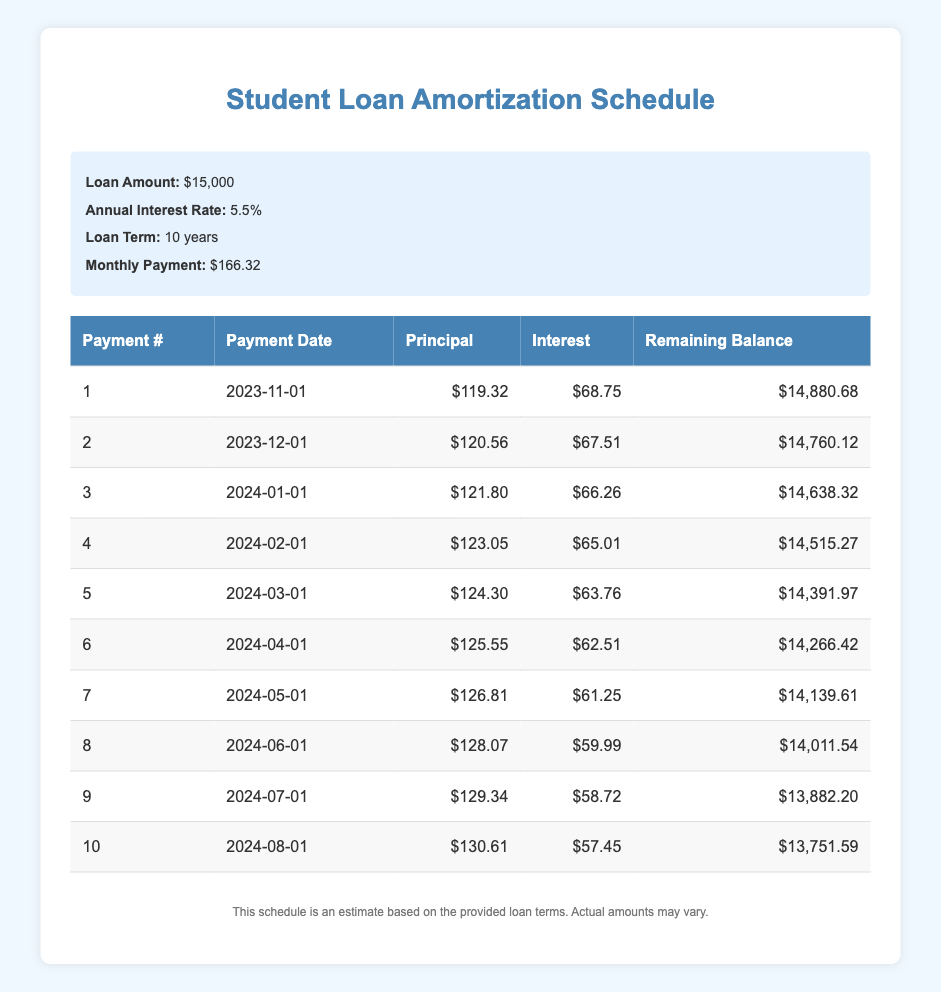What is the monthly payment for the student loan? The monthly payment is clearly stated in the loan details section of the table, which indicates it is $166.32.
Answer: $166.32 What is the principal payment for the first month? The principal payment for the first month is shown in the first row of the amortization schedule, listed as $119.32.
Answer: $119.32 How much interest is paid in the second month? The interest payment for the second month is directly visible in the second row, which specifies $67.51.
Answer: $67.51 What is the remaining balance after the fourth payment? The remaining balance is found in the fourth row of the table, where it shows a value of $14,515.27 after the fourth payment.
Answer: $14,515.27 How much total principal is paid in the first five months combined? To find this, we need to sum the principal payments for the first five payments: 119.32 + 120.56 + 121.80 + 123.05 + 124.30 = 609.03.
Answer: $609.03 Is the total interest paid in the first two months greater than the total principal paid in the same period? For the first two months, total interest paid is 68.75 + 67.51 = 136.26 and total principal paid is 119.32 + 120.56 = 239.88. Since 136.26 is less than 239.88, the statement is false.
Answer: No What is the average principal payment over the first ten months? To calculate the average principal payment, first find the total principal payments for the first ten months: 119.32 + 120.56 + 121.80 + 123.05 + 124.30 + 125.55 + 126.81 + 128.07 + 129.34 + 130.61 = 1,540.91. There are 10 payments, so the average is 1,540.91 / 10 = 154.09.
Answer: $154.09 What is the difference in interest payment between the fifth and the first month? The difference can be calculated by subtracting the interest payment of the first month from the fifth month: 63.76 - 68.75 = -4.99. This shows that the interest payment decreased by $4.99 from the first to the fifth month.
Answer: -$4.99 How much is remaining after the third payment? The remaining balance after the third payment is recorded in the third row of the table, which shows $14,638.32 after this payment.
Answer: $14,638.32 